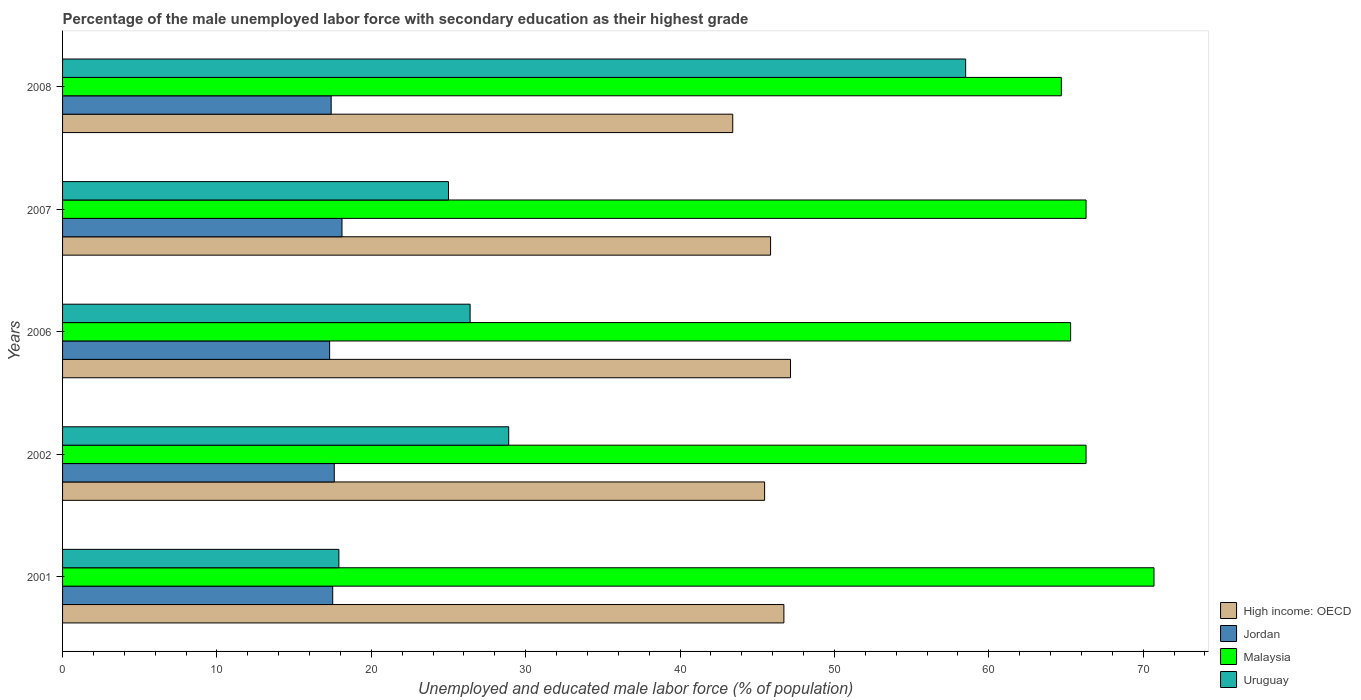Are the number of bars per tick equal to the number of legend labels?
Ensure brevity in your answer.  Yes. Are the number of bars on each tick of the Y-axis equal?
Offer a very short reply. Yes. How many bars are there on the 1st tick from the top?
Provide a succinct answer. 4. Across all years, what is the maximum percentage of the unemployed male labor force with secondary education in High income: OECD?
Make the answer very short. 47.16. Across all years, what is the minimum percentage of the unemployed male labor force with secondary education in Malaysia?
Give a very brief answer. 64.7. What is the total percentage of the unemployed male labor force with secondary education in Malaysia in the graph?
Give a very brief answer. 333.3. What is the difference between the percentage of the unemployed male labor force with secondary education in High income: OECD in 2001 and that in 2007?
Your answer should be compact. 0.86. What is the difference between the percentage of the unemployed male labor force with secondary education in High income: OECD in 2006 and the percentage of the unemployed male labor force with secondary education in Jordan in 2001?
Give a very brief answer. 29.66. What is the average percentage of the unemployed male labor force with secondary education in Jordan per year?
Give a very brief answer. 17.58. In the year 2002, what is the difference between the percentage of the unemployed male labor force with secondary education in Malaysia and percentage of the unemployed male labor force with secondary education in Uruguay?
Provide a short and direct response. 37.4. What is the ratio of the percentage of the unemployed male labor force with secondary education in Jordan in 2001 to that in 2006?
Make the answer very short. 1.01. Is the percentage of the unemployed male labor force with secondary education in High income: OECD in 2002 less than that in 2007?
Make the answer very short. Yes. Is the difference between the percentage of the unemployed male labor force with secondary education in Malaysia in 2007 and 2008 greater than the difference between the percentage of the unemployed male labor force with secondary education in Uruguay in 2007 and 2008?
Offer a very short reply. Yes. What is the difference between the highest and the second highest percentage of the unemployed male labor force with secondary education in High income: OECD?
Provide a succinct answer. 0.43. In how many years, is the percentage of the unemployed male labor force with secondary education in High income: OECD greater than the average percentage of the unemployed male labor force with secondary education in High income: OECD taken over all years?
Offer a terse response. 3. Is the sum of the percentage of the unemployed male labor force with secondary education in Uruguay in 2006 and 2007 greater than the maximum percentage of the unemployed male labor force with secondary education in Malaysia across all years?
Ensure brevity in your answer.  No. What does the 4th bar from the top in 2008 represents?
Your answer should be compact. High income: OECD. What does the 2nd bar from the bottom in 2006 represents?
Your answer should be very brief. Jordan. How many legend labels are there?
Provide a succinct answer. 4. What is the title of the graph?
Ensure brevity in your answer.  Percentage of the male unemployed labor force with secondary education as their highest grade. What is the label or title of the X-axis?
Make the answer very short. Unemployed and educated male labor force (% of population). What is the label or title of the Y-axis?
Keep it short and to the point. Years. What is the Unemployed and educated male labor force (% of population) in High income: OECD in 2001?
Give a very brief answer. 46.73. What is the Unemployed and educated male labor force (% of population) in Jordan in 2001?
Give a very brief answer. 17.5. What is the Unemployed and educated male labor force (% of population) in Malaysia in 2001?
Ensure brevity in your answer.  70.7. What is the Unemployed and educated male labor force (% of population) of Uruguay in 2001?
Offer a terse response. 17.9. What is the Unemployed and educated male labor force (% of population) of High income: OECD in 2002?
Ensure brevity in your answer.  45.48. What is the Unemployed and educated male labor force (% of population) in Jordan in 2002?
Give a very brief answer. 17.6. What is the Unemployed and educated male labor force (% of population) in Malaysia in 2002?
Provide a short and direct response. 66.3. What is the Unemployed and educated male labor force (% of population) in Uruguay in 2002?
Your response must be concise. 28.9. What is the Unemployed and educated male labor force (% of population) in High income: OECD in 2006?
Make the answer very short. 47.16. What is the Unemployed and educated male labor force (% of population) of Jordan in 2006?
Give a very brief answer. 17.3. What is the Unemployed and educated male labor force (% of population) in Malaysia in 2006?
Give a very brief answer. 65.3. What is the Unemployed and educated male labor force (% of population) of Uruguay in 2006?
Make the answer very short. 26.4. What is the Unemployed and educated male labor force (% of population) in High income: OECD in 2007?
Your answer should be very brief. 45.86. What is the Unemployed and educated male labor force (% of population) of Jordan in 2007?
Your response must be concise. 18.1. What is the Unemployed and educated male labor force (% of population) of Malaysia in 2007?
Your answer should be compact. 66.3. What is the Unemployed and educated male labor force (% of population) of High income: OECD in 2008?
Offer a very short reply. 43.41. What is the Unemployed and educated male labor force (% of population) in Jordan in 2008?
Provide a short and direct response. 17.4. What is the Unemployed and educated male labor force (% of population) of Malaysia in 2008?
Your response must be concise. 64.7. What is the Unemployed and educated male labor force (% of population) of Uruguay in 2008?
Your answer should be very brief. 58.5. Across all years, what is the maximum Unemployed and educated male labor force (% of population) in High income: OECD?
Your response must be concise. 47.16. Across all years, what is the maximum Unemployed and educated male labor force (% of population) of Jordan?
Offer a very short reply. 18.1. Across all years, what is the maximum Unemployed and educated male labor force (% of population) of Malaysia?
Give a very brief answer. 70.7. Across all years, what is the maximum Unemployed and educated male labor force (% of population) in Uruguay?
Ensure brevity in your answer.  58.5. Across all years, what is the minimum Unemployed and educated male labor force (% of population) of High income: OECD?
Offer a very short reply. 43.41. Across all years, what is the minimum Unemployed and educated male labor force (% of population) in Jordan?
Keep it short and to the point. 17.3. Across all years, what is the minimum Unemployed and educated male labor force (% of population) of Malaysia?
Give a very brief answer. 64.7. Across all years, what is the minimum Unemployed and educated male labor force (% of population) of Uruguay?
Offer a terse response. 17.9. What is the total Unemployed and educated male labor force (% of population) in High income: OECD in the graph?
Ensure brevity in your answer.  228.63. What is the total Unemployed and educated male labor force (% of population) in Jordan in the graph?
Ensure brevity in your answer.  87.9. What is the total Unemployed and educated male labor force (% of population) in Malaysia in the graph?
Give a very brief answer. 333.3. What is the total Unemployed and educated male labor force (% of population) of Uruguay in the graph?
Give a very brief answer. 156.7. What is the difference between the Unemployed and educated male labor force (% of population) of High income: OECD in 2001 and that in 2002?
Provide a short and direct response. 1.25. What is the difference between the Unemployed and educated male labor force (% of population) of Jordan in 2001 and that in 2002?
Your response must be concise. -0.1. What is the difference between the Unemployed and educated male labor force (% of population) of Malaysia in 2001 and that in 2002?
Ensure brevity in your answer.  4.4. What is the difference between the Unemployed and educated male labor force (% of population) in Uruguay in 2001 and that in 2002?
Provide a succinct answer. -11. What is the difference between the Unemployed and educated male labor force (% of population) in High income: OECD in 2001 and that in 2006?
Keep it short and to the point. -0.43. What is the difference between the Unemployed and educated male labor force (% of population) of Jordan in 2001 and that in 2006?
Provide a succinct answer. 0.2. What is the difference between the Unemployed and educated male labor force (% of population) of Uruguay in 2001 and that in 2006?
Make the answer very short. -8.5. What is the difference between the Unemployed and educated male labor force (% of population) of High income: OECD in 2001 and that in 2007?
Make the answer very short. 0.86. What is the difference between the Unemployed and educated male labor force (% of population) in High income: OECD in 2001 and that in 2008?
Provide a succinct answer. 3.31. What is the difference between the Unemployed and educated male labor force (% of population) of Jordan in 2001 and that in 2008?
Give a very brief answer. 0.1. What is the difference between the Unemployed and educated male labor force (% of population) of Uruguay in 2001 and that in 2008?
Ensure brevity in your answer.  -40.6. What is the difference between the Unemployed and educated male labor force (% of population) in High income: OECD in 2002 and that in 2006?
Make the answer very short. -1.68. What is the difference between the Unemployed and educated male labor force (% of population) in High income: OECD in 2002 and that in 2007?
Keep it short and to the point. -0.39. What is the difference between the Unemployed and educated male labor force (% of population) of Jordan in 2002 and that in 2007?
Provide a short and direct response. -0.5. What is the difference between the Unemployed and educated male labor force (% of population) in Malaysia in 2002 and that in 2007?
Provide a succinct answer. 0. What is the difference between the Unemployed and educated male labor force (% of population) in High income: OECD in 2002 and that in 2008?
Give a very brief answer. 2.06. What is the difference between the Unemployed and educated male labor force (% of population) of Uruguay in 2002 and that in 2008?
Provide a short and direct response. -29.6. What is the difference between the Unemployed and educated male labor force (% of population) in High income: OECD in 2006 and that in 2007?
Your answer should be compact. 1.29. What is the difference between the Unemployed and educated male labor force (% of population) in Uruguay in 2006 and that in 2007?
Keep it short and to the point. 1.4. What is the difference between the Unemployed and educated male labor force (% of population) of High income: OECD in 2006 and that in 2008?
Offer a very short reply. 3.74. What is the difference between the Unemployed and educated male labor force (% of population) of Uruguay in 2006 and that in 2008?
Make the answer very short. -32.1. What is the difference between the Unemployed and educated male labor force (% of population) of High income: OECD in 2007 and that in 2008?
Give a very brief answer. 2.45. What is the difference between the Unemployed and educated male labor force (% of population) in Malaysia in 2007 and that in 2008?
Your response must be concise. 1.6. What is the difference between the Unemployed and educated male labor force (% of population) in Uruguay in 2007 and that in 2008?
Make the answer very short. -33.5. What is the difference between the Unemployed and educated male labor force (% of population) in High income: OECD in 2001 and the Unemployed and educated male labor force (% of population) in Jordan in 2002?
Ensure brevity in your answer.  29.13. What is the difference between the Unemployed and educated male labor force (% of population) of High income: OECD in 2001 and the Unemployed and educated male labor force (% of population) of Malaysia in 2002?
Ensure brevity in your answer.  -19.57. What is the difference between the Unemployed and educated male labor force (% of population) in High income: OECD in 2001 and the Unemployed and educated male labor force (% of population) in Uruguay in 2002?
Make the answer very short. 17.83. What is the difference between the Unemployed and educated male labor force (% of population) in Jordan in 2001 and the Unemployed and educated male labor force (% of population) in Malaysia in 2002?
Ensure brevity in your answer.  -48.8. What is the difference between the Unemployed and educated male labor force (% of population) in Jordan in 2001 and the Unemployed and educated male labor force (% of population) in Uruguay in 2002?
Make the answer very short. -11.4. What is the difference between the Unemployed and educated male labor force (% of population) of Malaysia in 2001 and the Unemployed and educated male labor force (% of population) of Uruguay in 2002?
Your answer should be very brief. 41.8. What is the difference between the Unemployed and educated male labor force (% of population) in High income: OECD in 2001 and the Unemployed and educated male labor force (% of population) in Jordan in 2006?
Your answer should be compact. 29.43. What is the difference between the Unemployed and educated male labor force (% of population) of High income: OECD in 2001 and the Unemployed and educated male labor force (% of population) of Malaysia in 2006?
Ensure brevity in your answer.  -18.57. What is the difference between the Unemployed and educated male labor force (% of population) in High income: OECD in 2001 and the Unemployed and educated male labor force (% of population) in Uruguay in 2006?
Your response must be concise. 20.33. What is the difference between the Unemployed and educated male labor force (% of population) of Jordan in 2001 and the Unemployed and educated male labor force (% of population) of Malaysia in 2006?
Make the answer very short. -47.8. What is the difference between the Unemployed and educated male labor force (% of population) in Jordan in 2001 and the Unemployed and educated male labor force (% of population) in Uruguay in 2006?
Your answer should be very brief. -8.9. What is the difference between the Unemployed and educated male labor force (% of population) of Malaysia in 2001 and the Unemployed and educated male labor force (% of population) of Uruguay in 2006?
Give a very brief answer. 44.3. What is the difference between the Unemployed and educated male labor force (% of population) in High income: OECD in 2001 and the Unemployed and educated male labor force (% of population) in Jordan in 2007?
Your answer should be compact. 28.63. What is the difference between the Unemployed and educated male labor force (% of population) in High income: OECD in 2001 and the Unemployed and educated male labor force (% of population) in Malaysia in 2007?
Offer a terse response. -19.57. What is the difference between the Unemployed and educated male labor force (% of population) of High income: OECD in 2001 and the Unemployed and educated male labor force (% of population) of Uruguay in 2007?
Offer a terse response. 21.73. What is the difference between the Unemployed and educated male labor force (% of population) in Jordan in 2001 and the Unemployed and educated male labor force (% of population) in Malaysia in 2007?
Give a very brief answer. -48.8. What is the difference between the Unemployed and educated male labor force (% of population) in Malaysia in 2001 and the Unemployed and educated male labor force (% of population) in Uruguay in 2007?
Your response must be concise. 45.7. What is the difference between the Unemployed and educated male labor force (% of population) of High income: OECD in 2001 and the Unemployed and educated male labor force (% of population) of Jordan in 2008?
Offer a terse response. 29.33. What is the difference between the Unemployed and educated male labor force (% of population) of High income: OECD in 2001 and the Unemployed and educated male labor force (% of population) of Malaysia in 2008?
Your response must be concise. -17.97. What is the difference between the Unemployed and educated male labor force (% of population) in High income: OECD in 2001 and the Unemployed and educated male labor force (% of population) in Uruguay in 2008?
Offer a very short reply. -11.77. What is the difference between the Unemployed and educated male labor force (% of population) in Jordan in 2001 and the Unemployed and educated male labor force (% of population) in Malaysia in 2008?
Ensure brevity in your answer.  -47.2. What is the difference between the Unemployed and educated male labor force (% of population) of Jordan in 2001 and the Unemployed and educated male labor force (% of population) of Uruguay in 2008?
Offer a terse response. -41. What is the difference between the Unemployed and educated male labor force (% of population) of High income: OECD in 2002 and the Unemployed and educated male labor force (% of population) of Jordan in 2006?
Offer a very short reply. 28.18. What is the difference between the Unemployed and educated male labor force (% of population) of High income: OECD in 2002 and the Unemployed and educated male labor force (% of population) of Malaysia in 2006?
Offer a terse response. -19.82. What is the difference between the Unemployed and educated male labor force (% of population) in High income: OECD in 2002 and the Unemployed and educated male labor force (% of population) in Uruguay in 2006?
Give a very brief answer. 19.08. What is the difference between the Unemployed and educated male labor force (% of population) of Jordan in 2002 and the Unemployed and educated male labor force (% of population) of Malaysia in 2006?
Provide a short and direct response. -47.7. What is the difference between the Unemployed and educated male labor force (% of population) in Malaysia in 2002 and the Unemployed and educated male labor force (% of population) in Uruguay in 2006?
Provide a succinct answer. 39.9. What is the difference between the Unemployed and educated male labor force (% of population) in High income: OECD in 2002 and the Unemployed and educated male labor force (% of population) in Jordan in 2007?
Make the answer very short. 27.38. What is the difference between the Unemployed and educated male labor force (% of population) in High income: OECD in 2002 and the Unemployed and educated male labor force (% of population) in Malaysia in 2007?
Keep it short and to the point. -20.82. What is the difference between the Unemployed and educated male labor force (% of population) of High income: OECD in 2002 and the Unemployed and educated male labor force (% of population) of Uruguay in 2007?
Keep it short and to the point. 20.48. What is the difference between the Unemployed and educated male labor force (% of population) of Jordan in 2002 and the Unemployed and educated male labor force (% of population) of Malaysia in 2007?
Provide a short and direct response. -48.7. What is the difference between the Unemployed and educated male labor force (% of population) of Malaysia in 2002 and the Unemployed and educated male labor force (% of population) of Uruguay in 2007?
Provide a short and direct response. 41.3. What is the difference between the Unemployed and educated male labor force (% of population) of High income: OECD in 2002 and the Unemployed and educated male labor force (% of population) of Jordan in 2008?
Make the answer very short. 28.08. What is the difference between the Unemployed and educated male labor force (% of population) in High income: OECD in 2002 and the Unemployed and educated male labor force (% of population) in Malaysia in 2008?
Provide a short and direct response. -19.22. What is the difference between the Unemployed and educated male labor force (% of population) in High income: OECD in 2002 and the Unemployed and educated male labor force (% of population) in Uruguay in 2008?
Your response must be concise. -13.02. What is the difference between the Unemployed and educated male labor force (% of population) of Jordan in 2002 and the Unemployed and educated male labor force (% of population) of Malaysia in 2008?
Offer a very short reply. -47.1. What is the difference between the Unemployed and educated male labor force (% of population) of Jordan in 2002 and the Unemployed and educated male labor force (% of population) of Uruguay in 2008?
Offer a very short reply. -40.9. What is the difference between the Unemployed and educated male labor force (% of population) of Malaysia in 2002 and the Unemployed and educated male labor force (% of population) of Uruguay in 2008?
Provide a succinct answer. 7.8. What is the difference between the Unemployed and educated male labor force (% of population) of High income: OECD in 2006 and the Unemployed and educated male labor force (% of population) of Jordan in 2007?
Give a very brief answer. 29.05. What is the difference between the Unemployed and educated male labor force (% of population) in High income: OECD in 2006 and the Unemployed and educated male labor force (% of population) in Malaysia in 2007?
Provide a succinct answer. -19.14. What is the difference between the Unemployed and educated male labor force (% of population) in High income: OECD in 2006 and the Unemployed and educated male labor force (% of population) in Uruguay in 2007?
Keep it short and to the point. 22.16. What is the difference between the Unemployed and educated male labor force (% of population) of Jordan in 2006 and the Unemployed and educated male labor force (% of population) of Malaysia in 2007?
Offer a terse response. -49. What is the difference between the Unemployed and educated male labor force (% of population) of Jordan in 2006 and the Unemployed and educated male labor force (% of population) of Uruguay in 2007?
Offer a very short reply. -7.7. What is the difference between the Unemployed and educated male labor force (% of population) of Malaysia in 2006 and the Unemployed and educated male labor force (% of population) of Uruguay in 2007?
Keep it short and to the point. 40.3. What is the difference between the Unemployed and educated male labor force (% of population) of High income: OECD in 2006 and the Unemployed and educated male labor force (% of population) of Jordan in 2008?
Keep it short and to the point. 29.75. What is the difference between the Unemployed and educated male labor force (% of population) in High income: OECD in 2006 and the Unemployed and educated male labor force (% of population) in Malaysia in 2008?
Provide a short and direct response. -17.55. What is the difference between the Unemployed and educated male labor force (% of population) in High income: OECD in 2006 and the Unemployed and educated male labor force (% of population) in Uruguay in 2008?
Your answer should be very brief. -11.35. What is the difference between the Unemployed and educated male labor force (% of population) of Jordan in 2006 and the Unemployed and educated male labor force (% of population) of Malaysia in 2008?
Provide a short and direct response. -47.4. What is the difference between the Unemployed and educated male labor force (% of population) of Jordan in 2006 and the Unemployed and educated male labor force (% of population) of Uruguay in 2008?
Offer a very short reply. -41.2. What is the difference between the Unemployed and educated male labor force (% of population) of Malaysia in 2006 and the Unemployed and educated male labor force (% of population) of Uruguay in 2008?
Offer a terse response. 6.8. What is the difference between the Unemployed and educated male labor force (% of population) in High income: OECD in 2007 and the Unemployed and educated male labor force (% of population) in Jordan in 2008?
Give a very brief answer. 28.46. What is the difference between the Unemployed and educated male labor force (% of population) in High income: OECD in 2007 and the Unemployed and educated male labor force (% of population) in Malaysia in 2008?
Keep it short and to the point. -18.84. What is the difference between the Unemployed and educated male labor force (% of population) in High income: OECD in 2007 and the Unemployed and educated male labor force (% of population) in Uruguay in 2008?
Provide a short and direct response. -12.64. What is the difference between the Unemployed and educated male labor force (% of population) in Jordan in 2007 and the Unemployed and educated male labor force (% of population) in Malaysia in 2008?
Keep it short and to the point. -46.6. What is the difference between the Unemployed and educated male labor force (% of population) in Jordan in 2007 and the Unemployed and educated male labor force (% of population) in Uruguay in 2008?
Keep it short and to the point. -40.4. What is the difference between the Unemployed and educated male labor force (% of population) in Malaysia in 2007 and the Unemployed and educated male labor force (% of population) in Uruguay in 2008?
Your answer should be very brief. 7.8. What is the average Unemployed and educated male labor force (% of population) of High income: OECD per year?
Provide a succinct answer. 45.73. What is the average Unemployed and educated male labor force (% of population) of Jordan per year?
Ensure brevity in your answer.  17.58. What is the average Unemployed and educated male labor force (% of population) of Malaysia per year?
Give a very brief answer. 66.66. What is the average Unemployed and educated male labor force (% of population) in Uruguay per year?
Make the answer very short. 31.34. In the year 2001, what is the difference between the Unemployed and educated male labor force (% of population) in High income: OECD and Unemployed and educated male labor force (% of population) in Jordan?
Keep it short and to the point. 29.23. In the year 2001, what is the difference between the Unemployed and educated male labor force (% of population) in High income: OECD and Unemployed and educated male labor force (% of population) in Malaysia?
Provide a succinct answer. -23.97. In the year 2001, what is the difference between the Unemployed and educated male labor force (% of population) in High income: OECD and Unemployed and educated male labor force (% of population) in Uruguay?
Offer a very short reply. 28.83. In the year 2001, what is the difference between the Unemployed and educated male labor force (% of population) of Jordan and Unemployed and educated male labor force (% of population) of Malaysia?
Give a very brief answer. -53.2. In the year 2001, what is the difference between the Unemployed and educated male labor force (% of population) in Malaysia and Unemployed and educated male labor force (% of population) in Uruguay?
Keep it short and to the point. 52.8. In the year 2002, what is the difference between the Unemployed and educated male labor force (% of population) of High income: OECD and Unemployed and educated male labor force (% of population) of Jordan?
Your response must be concise. 27.88. In the year 2002, what is the difference between the Unemployed and educated male labor force (% of population) of High income: OECD and Unemployed and educated male labor force (% of population) of Malaysia?
Ensure brevity in your answer.  -20.82. In the year 2002, what is the difference between the Unemployed and educated male labor force (% of population) of High income: OECD and Unemployed and educated male labor force (% of population) of Uruguay?
Provide a succinct answer. 16.58. In the year 2002, what is the difference between the Unemployed and educated male labor force (% of population) of Jordan and Unemployed and educated male labor force (% of population) of Malaysia?
Keep it short and to the point. -48.7. In the year 2002, what is the difference between the Unemployed and educated male labor force (% of population) of Malaysia and Unemployed and educated male labor force (% of population) of Uruguay?
Make the answer very short. 37.4. In the year 2006, what is the difference between the Unemployed and educated male labor force (% of population) of High income: OECD and Unemployed and educated male labor force (% of population) of Jordan?
Your answer should be compact. 29.86. In the year 2006, what is the difference between the Unemployed and educated male labor force (% of population) in High income: OECD and Unemployed and educated male labor force (% of population) in Malaysia?
Make the answer very short. -18.14. In the year 2006, what is the difference between the Unemployed and educated male labor force (% of population) in High income: OECD and Unemployed and educated male labor force (% of population) in Uruguay?
Keep it short and to the point. 20.75. In the year 2006, what is the difference between the Unemployed and educated male labor force (% of population) of Jordan and Unemployed and educated male labor force (% of population) of Malaysia?
Keep it short and to the point. -48. In the year 2006, what is the difference between the Unemployed and educated male labor force (% of population) of Jordan and Unemployed and educated male labor force (% of population) of Uruguay?
Ensure brevity in your answer.  -9.1. In the year 2006, what is the difference between the Unemployed and educated male labor force (% of population) in Malaysia and Unemployed and educated male labor force (% of population) in Uruguay?
Give a very brief answer. 38.9. In the year 2007, what is the difference between the Unemployed and educated male labor force (% of population) in High income: OECD and Unemployed and educated male labor force (% of population) in Jordan?
Keep it short and to the point. 27.76. In the year 2007, what is the difference between the Unemployed and educated male labor force (% of population) of High income: OECD and Unemployed and educated male labor force (% of population) of Malaysia?
Your answer should be compact. -20.44. In the year 2007, what is the difference between the Unemployed and educated male labor force (% of population) in High income: OECD and Unemployed and educated male labor force (% of population) in Uruguay?
Provide a short and direct response. 20.86. In the year 2007, what is the difference between the Unemployed and educated male labor force (% of population) in Jordan and Unemployed and educated male labor force (% of population) in Malaysia?
Provide a short and direct response. -48.2. In the year 2007, what is the difference between the Unemployed and educated male labor force (% of population) of Jordan and Unemployed and educated male labor force (% of population) of Uruguay?
Offer a very short reply. -6.9. In the year 2007, what is the difference between the Unemployed and educated male labor force (% of population) in Malaysia and Unemployed and educated male labor force (% of population) in Uruguay?
Your answer should be compact. 41.3. In the year 2008, what is the difference between the Unemployed and educated male labor force (% of population) of High income: OECD and Unemployed and educated male labor force (% of population) of Jordan?
Offer a terse response. 26.01. In the year 2008, what is the difference between the Unemployed and educated male labor force (% of population) of High income: OECD and Unemployed and educated male labor force (% of population) of Malaysia?
Your response must be concise. -21.29. In the year 2008, what is the difference between the Unemployed and educated male labor force (% of population) in High income: OECD and Unemployed and educated male labor force (% of population) in Uruguay?
Ensure brevity in your answer.  -15.09. In the year 2008, what is the difference between the Unemployed and educated male labor force (% of population) of Jordan and Unemployed and educated male labor force (% of population) of Malaysia?
Provide a short and direct response. -47.3. In the year 2008, what is the difference between the Unemployed and educated male labor force (% of population) in Jordan and Unemployed and educated male labor force (% of population) in Uruguay?
Your answer should be compact. -41.1. In the year 2008, what is the difference between the Unemployed and educated male labor force (% of population) in Malaysia and Unemployed and educated male labor force (% of population) in Uruguay?
Give a very brief answer. 6.2. What is the ratio of the Unemployed and educated male labor force (% of population) in High income: OECD in 2001 to that in 2002?
Give a very brief answer. 1.03. What is the ratio of the Unemployed and educated male labor force (% of population) of Malaysia in 2001 to that in 2002?
Offer a terse response. 1.07. What is the ratio of the Unemployed and educated male labor force (% of population) of Uruguay in 2001 to that in 2002?
Ensure brevity in your answer.  0.62. What is the ratio of the Unemployed and educated male labor force (% of population) of High income: OECD in 2001 to that in 2006?
Give a very brief answer. 0.99. What is the ratio of the Unemployed and educated male labor force (% of population) of Jordan in 2001 to that in 2006?
Your response must be concise. 1.01. What is the ratio of the Unemployed and educated male labor force (% of population) of Malaysia in 2001 to that in 2006?
Your answer should be very brief. 1.08. What is the ratio of the Unemployed and educated male labor force (% of population) of Uruguay in 2001 to that in 2006?
Offer a very short reply. 0.68. What is the ratio of the Unemployed and educated male labor force (% of population) in High income: OECD in 2001 to that in 2007?
Your answer should be compact. 1.02. What is the ratio of the Unemployed and educated male labor force (% of population) in Jordan in 2001 to that in 2007?
Your answer should be very brief. 0.97. What is the ratio of the Unemployed and educated male labor force (% of population) in Malaysia in 2001 to that in 2007?
Ensure brevity in your answer.  1.07. What is the ratio of the Unemployed and educated male labor force (% of population) of Uruguay in 2001 to that in 2007?
Ensure brevity in your answer.  0.72. What is the ratio of the Unemployed and educated male labor force (% of population) of High income: OECD in 2001 to that in 2008?
Keep it short and to the point. 1.08. What is the ratio of the Unemployed and educated male labor force (% of population) of Malaysia in 2001 to that in 2008?
Provide a short and direct response. 1.09. What is the ratio of the Unemployed and educated male labor force (% of population) of Uruguay in 2001 to that in 2008?
Offer a very short reply. 0.31. What is the ratio of the Unemployed and educated male labor force (% of population) of High income: OECD in 2002 to that in 2006?
Provide a short and direct response. 0.96. What is the ratio of the Unemployed and educated male labor force (% of population) of Jordan in 2002 to that in 2006?
Make the answer very short. 1.02. What is the ratio of the Unemployed and educated male labor force (% of population) in Malaysia in 2002 to that in 2006?
Make the answer very short. 1.02. What is the ratio of the Unemployed and educated male labor force (% of population) in Uruguay in 2002 to that in 2006?
Keep it short and to the point. 1.09. What is the ratio of the Unemployed and educated male labor force (% of population) of High income: OECD in 2002 to that in 2007?
Your response must be concise. 0.99. What is the ratio of the Unemployed and educated male labor force (% of population) of Jordan in 2002 to that in 2007?
Provide a succinct answer. 0.97. What is the ratio of the Unemployed and educated male labor force (% of population) in Uruguay in 2002 to that in 2007?
Provide a short and direct response. 1.16. What is the ratio of the Unemployed and educated male labor force (% of population) in High income: OECD in 2002 to that in 2008?
Your answer should be very brief. 1.05. What is the ratio of the Unemployed and educated male labor force (% of population) of Jordan in 2002 to that in 2008?
Give a very brief answer. 1.01. What is the ratio of the Unemployed and educated male labor force (% of population) in Malaysia in 2002 to that in 2008?
Give a very brief answer. 1.02. What is the ratio of the Unemployed and educated male labor force (% of population) in Uruguay in 2002 to that in 2008?
Provide a succinct answer. 0.49. What is the ratio of the Unemployed and educated male labor force (% of population) in High income: OECD in 2006 to that in 2007?
Your answer should be very brief. 1.03. What is the ratio of the Unemployed and educated male labor force (% of population) of Jordan in 2006 to that in 2007?
Make the answer very short. 0.96. What is the ratio of the Unemployed and educated male labor force (% of population) in Malaysia in 2006 to that in 2007?
Keep it short and to the point. 0.98. What is the ratio of the Unemployed and educated male labor force (% of population) of Uruguay in 2006 to that in 2007?
Your answer should be very brief. 1.06. What is the ratio of the Unemployed and educated male labor force (% of population) in High income: OECD in 2006 to that in 2008?
Give a very brief answer. 1.09. What is the ratio of the Unemployed and educated male labor force (% of population) in Malaysia in 2006 to that in 2008?
Offer a terse response. 1.01. What is the ratio of the Unemployed and educated male labor force (% of population) in Uruguay in 2006 to that in 2008?
Offer a terse response. 0.45. What is the ratio of the Unemployed and educated male labor force (% of population) of High income: OECD in 2007 to that in 2008?
Your response must be concise. 1.06. What is the ratio of the Unemployed and educated male labor force (% of population) in Jordan in 2007 to that in 2008?
Offer a terse response. 1.04. What is the ratio of the Unemployed and educated male labor force (% of population) in Malaysia in 2007 to that in 2008?
Offer a very short reply. 1.02. What is the ratio of the Unemployed and educated male labor force (% of population) in Uruguay in 2007 to that in 2008?
Your answer should be compact. 0.43. What is the difference between the highest and the second highest Unemployed and educated male labor force (% of population) in High income: OECD?
Keep it short and to the point. 0.43. What is the difference between the highest and the second highest Unemployed and educated male labor force (% of population) of Jordan?
Offer a very short reply. 0.5. What is the difference between the highest and the second highest Unemployed and educated male labor force (% of population) of Uruguay?
Offer a very short reply. 29.6. What is the difference between the highest and the lowest Unemployed and educated male labor force (% of population) in High income: OECD?
Give a very brief answer. 3.74. What is the difference between the highest and the lowest Unemployed and educated male labor force (% of population) of Malaysia?
Your response must be concise. 6. What is the difference between the highest and the lowest Unemployed and educated male labor force (% of population) of Uruguay?
Provide a short and direct response. 40.6. 